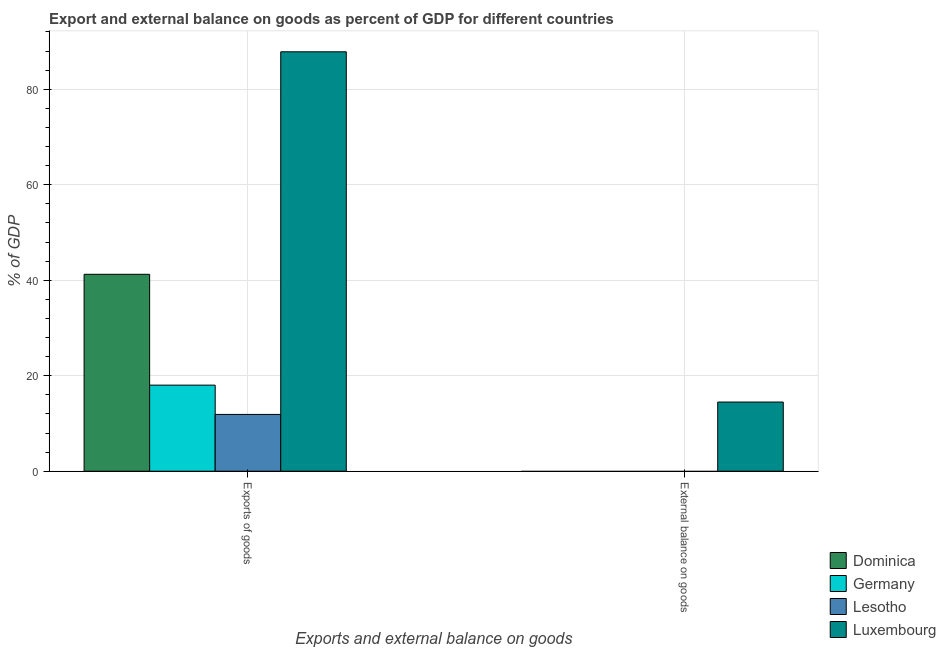How many different coloured bars are there?
Provide a short and direct response. 4. What is the label of the 2nd group of bars from the left?
Make the answer very short. External balance on goods. What is the export of goods as percentage of gdp in Luxembourg?
Offer a very short reply. 87.84. Across all countries, what is the maximum external balance on goods as percentage of gdp?
Offer a very short reply. 14.49. In which country was the export of goods as percentage of gdp maximum?
Provide a succinct answer. Luxembourg. What is the total external balance on goods as percentage of gdp in the graph?
Provide a short and direct response. 14.49. What is the difference between the export of goods as percentage of gdp in Lesotho and that in Luxembourg?
Your answer should be compact. -75.94. What is the difference between the export of goods as percentage of gdp in Dominica and the external balance on goods as percentage of gdp in Germany?
Your answer should be very brief. 41.24. What is the average external balance on goods as percentage of gdp per country?
Offer a very short reply. 3.62. What is the difference between the external balance on goods as percentage of gdp and export of goods as percentage of gdp in Luxembourg?
Keep it short and to the point. -73.35. In how many countries, is the export of goods as percentage of gdp greater than 36 %?
Keep it short and to the point. 2. What is the ratio of the export of goods as percentage of gdp in Dominica to that in Germany?
Your answer should be very brief. 2.29. Is the export of goods as percentage of gdp in Lesotho less than that in Germany?
Your response must be concise. Yes. How many bars are there?
Your response must be concise. 5. What is the difference between two consecutive major ticks on the Y-axis?
Keep it short and to the point. 20. How are the legend labels stacked?
Your response must be concise. Vertical. What is the title of the graph?
Make the answer very short. Export and external balance on goods as percent of GDP for different countries. What is the label or title of the X-axis?
Your answer should be compact. Exports and external balance on goods. What is the label or title of the Y-axis?
Make the answer very short. % of GDP. What is the % of GDP of Dominica in Exports of goods?
Your answer should be very brief. 41.24. What is the % of GDP of Germany in Exports of goods?
Your response must be concise. 18.03. What is the % of GDP in Lesotho in Exports of goods?
Ensure brevity in your answer.  11.9. What is the % of GDP of Luxembourg in Exports of goods?
Keep it short and to the point. 87.84. What is the % of GDP of Dominica in External balance on goods?
Your response must be concise. 0. What is the % of GDP in Luxembourg in External balance on goods?
Offer a very short reply. 14.49. Across all Exports and external balance on goods, what is the maximum % of GDP in Dominica?
Make the answer very short. 41.24. Across all Exports and external balance on goods, what is the maximum % of GDP of Germany?
Provide a succinct answer. 18.03. Across all Exports and external balance on goods, what is the maximum % of GDP in Lesotho?
Your answer should be very brief. 11.9. Across all Exports and external balance on goods, what is the maximum % of GDP in Luxembourg?
Your response must be concise. 87.84. Across all Exports and external balance on goods, what is the minimum % of GDP in Lesotho?
Give a very brief answer. 0. Across all Exports and external balance on goods, what is the minimum % of GDP of Luxembourg?
Offer a terse response. 14.49. What is the total % of GDP in Dominica in the graph?
Ensure brevity in your answer.  41.24. What is the total % of GDP of Germany in the graph?
Offer a very short reply. 18.03. What is the total % of GDP in Lesotho in the graph?
Keep it short and to the point. 11.9. What is the total % of GDP of Luxembourg in the graph?
Your answer should be very brief. 102.33. What is the difference between the % of GDP of Luxembourg in Exports of goods and that in External balance on goods?
Give a very brief answer. 73.35. What is the difference between the % of GDP of Dominica in Exports of goods and the % of GDP of Luxembourg in External balance on goods?
Give a very brief answer. 26.75. What is the difference between the % of GDP of Germany in Exports of goods and the % of GDP of Luxembourg in External balance on goods?
Provide a short and direct response. 3.54. What is the difference between the % of GDP in Lesotho in Exports of goods and the % of GDP in Luxembourg in External balance on goods?
Make the answer very short. -2.59. What is the average % of GDP of Dominica per Exports and external balance on goods?
Provide a succinct answer. 20.62. What is the average % of GDP of Germany per Exports and external balance on goods?
Your response must be concise. 9.01. What is the average % of GDP of Lesotho per Exports and external balance on goods?
Your answer should be very brief. 5.95. What is the average % of GDP in Luxembourg per Exports and external balance on goods?
Provide a short and direct response. 51.17. What is the difference between the % of GDP of Dominica and % of GDP of Germany in Exports of goods?
Make the answer very short. 23.21. What is the difference between the % of GDP in Dominica and % of GDP in Lesotho in Exports of goods?
Make the answer very short. 29.34. What is the difference between the % of GDP in Dominica and % of GDP in Luxembourg in Exports of goods?
Offer a terse response. -46.6. What is the difference between the % of GDP of Germany and % of GDP of Lesotho in Exports of goods?
Provide a succinct answer. 6.13. What is the difference between the % of GDP of Germany and % of GDP of Luxembourg in Exports of goods?
Your answer should be very brief. -69.81. What is the difference between the % of GDP in Lesotho and % of GDP in Luxembourg in Exports of goods?
Keep it short and to the point. -75.94. What is the ratio of the % of GDP in Luxembourg in Exports of goods to that in External balance on goods?
Offer a very short reply. 6.06. What is the difference between the highest and the second highest % of GDP in Luxembourg?
Ensure brevity in your answer.  73.35. What is the difference between the highest and the lowest % of GDP of Dominica?
Provide a short and direct response. 41.24. What is the difference between the highest and the lowest % of GDP in Germany?
Ensure brevity in your answer.  18.03. What is the difference between the highest and the lowest % of GDP in Lesotho?
Provide a short and direct response. 11.9. What is the difference between the highest and the lowest % of GDP of Luxembourg?
Your response must be concise. 73.35. 